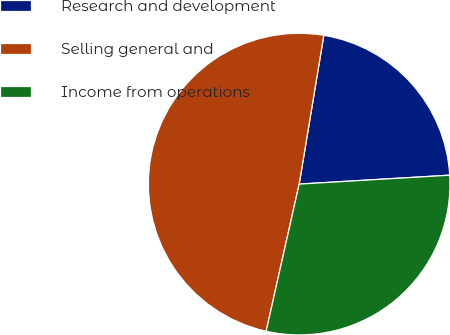<chart> <loc_0><loc_0><loc_500><loc_500><pie_chart><fcel>Research and development<fcel>Selling general and<fcel>Income from operations<nl><fcel>21.45%<fcel>49.1%<fcel>29.46%<nl></chart> 